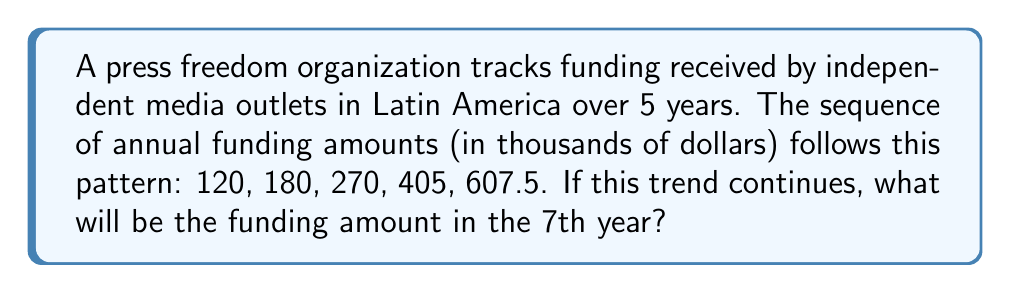Teach me how to tackle this problem. To solve this problem, we need to analyze the sequence and identify the pattern:

1. First, let's calculate the ratio between consecutive terms:
   $\frac{180}{120} = 1.5$
   $\frac{270}{180} = 1.5$
   $\frac{405}{270} = 1.5$
   $\frac{607.5}{405} = 1.5$

2. We can see that each term is 1.5 times the previous term. This is a geometric sequence with a common ratio of 1.5.

3. The general formula for a geometric sequence is:
   $a_n = a_1 \cdot r^{n-1}$
   Where $a_n$ is the nth term, $a_1$ is the first term, and $r$ is the common ratio.

4. In this case:
   $a_1 = 120$
   $r = 1.5$

5. We need to find the 7th term, so n = 7:
   $a_7 = 120 \cdot (1.5)^{7-1}$
   $a_7 = 120 \cdot (1.5)^6$

6. Calculate:
   $a_7 = 120 \cdot 11.390625$
   $a_7 = 1366.875$

Therefore, the funding amount in the 7th year will be $1366.875 thousand, or $1,366,875.
Answer: $1,366,875 